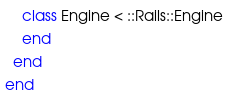Convert code to text. <code><loc_0><loc_0><loc_500><loc_500><_Ruby_>    class Engine < ::Rails::Engine
    end
  end
end
</code> 